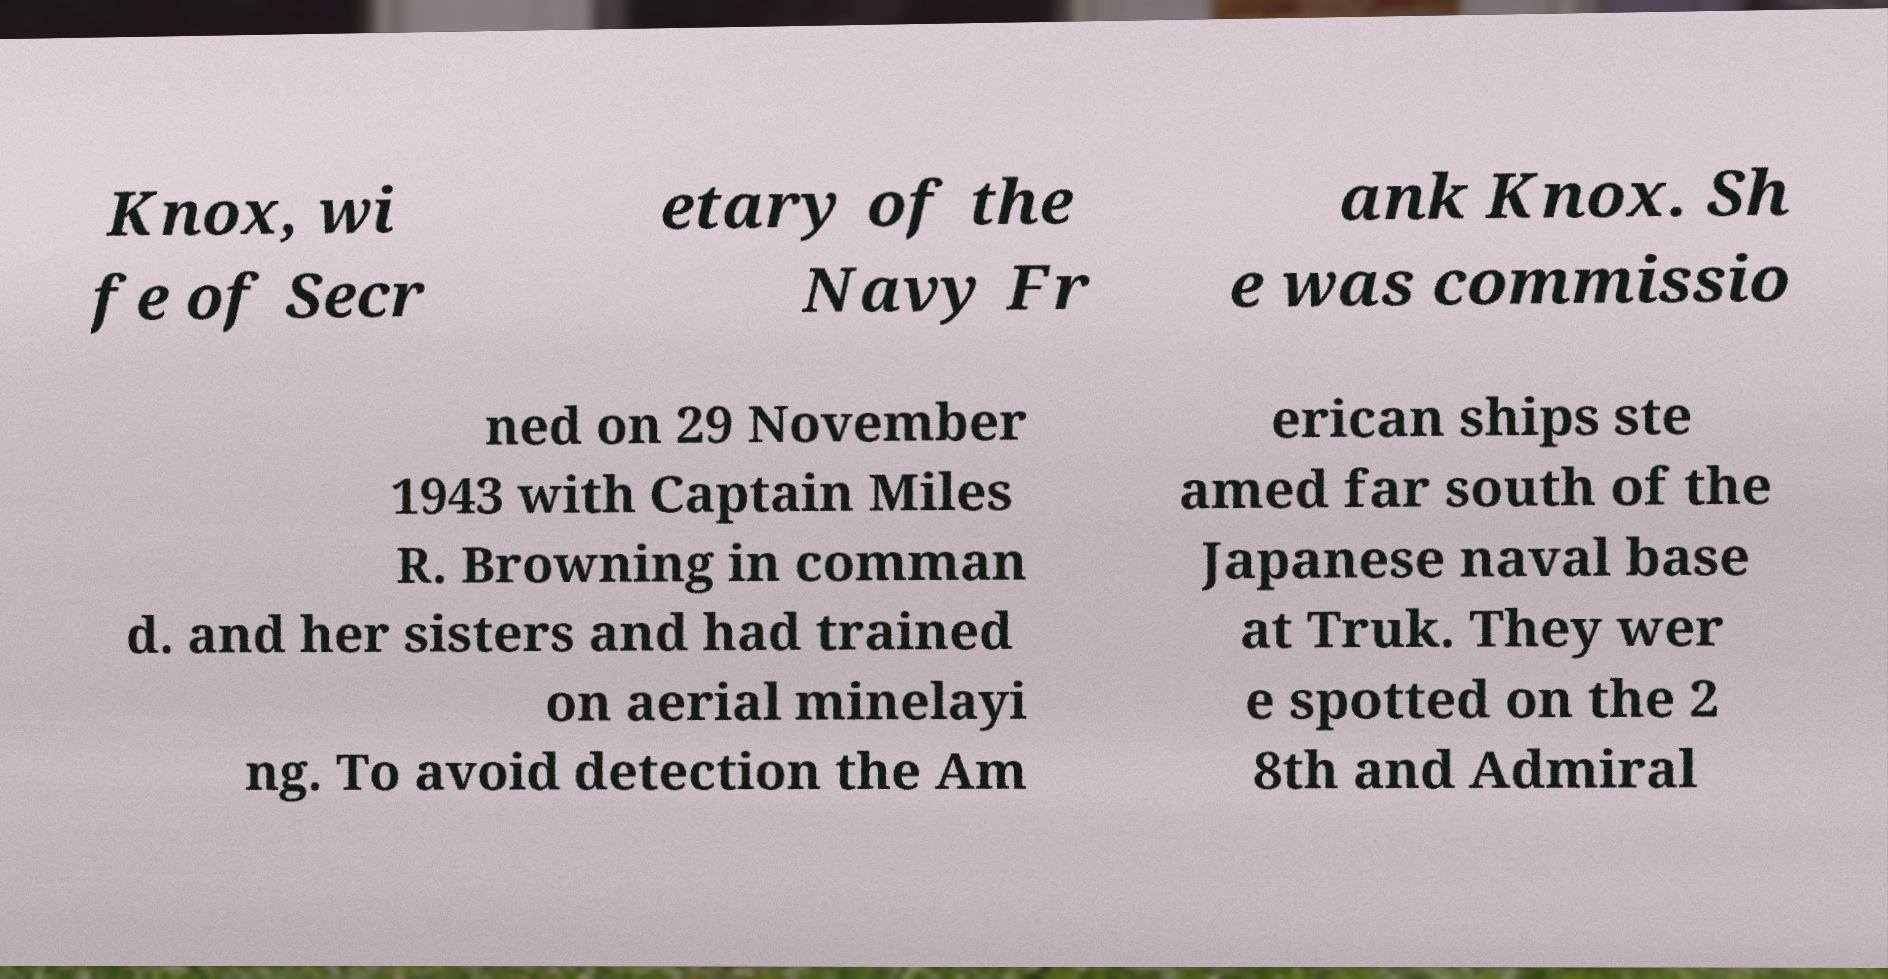Please read and relay the text visible in this image. What does it say? Knox, wi fe of Secr etary of the Navy Fr ank Knox. Sh e was commissio ned on 29 November 1943 with Captain Miles R. Browning in comman d. and her sisters and had trained on aerial minelayi ng. To avoid detection the Am erican ships ste amed far south of the Japanese naval base at Truk. They wer e spotted on the 2 8th and Admiral 